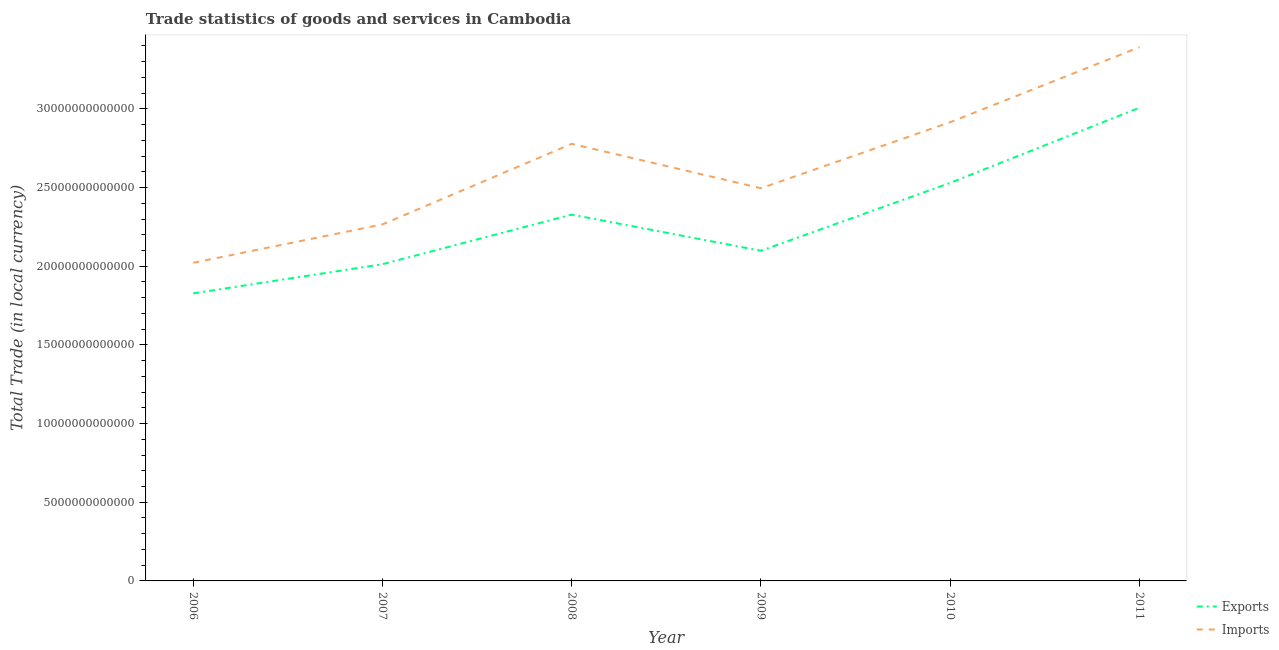Is the number of lines equal to the number of legend labels?
Your answer should be compact. Yes. What is the imports of goods and services in 2011?
Provide a short and direct response. 3.39e+13. Across all years, what is the maximum export of goods and services?
Make the answer very short. 3.01e+13. Across all years, what is the minimum export of goods and services?
Provide a short and direct response. 1.83e+13. In which year was the imports of goods and services maximum?
Offer a very short reply. 2011. What is the total imports of goods and services in the graph?
Give a very brief answer. 1.59e+14. What is the difference between the imports of goods and services in 2007 and that in 2009?
Offer a very short reply. -2.30e+12. What is the difference between the imports of goods and services in 2008 and the export of goods and services in 2010?
Your response must be concise. 2.48e+12. What is the average imports of goods and services per year?
Your response must be concise. 2.64e+13. In the year 2010, what is the difference between the imports of goods and services and export of goods and services?
Provide a succinct answer. 3.86e+12. What is the ratio of the imports of goods and services in 2008 to that in 2010?
Offer a very short reply. 0.95. Is the difference between the imports of goods and services in 2006 and 2011 greater than the difference between the export of goods and services in 2006 and 2011?
Provide a succinct answer. No. What is the difference between the highest and the second highest export of goods and services?
Give a very brief answer. 4.78e+12. What is the difference between the highest and the lowest export of goods and services?
Offer a very short reply. 1.18e+13. Does the imports of goods and services monotonically increase over the years?
Your answer should be compact. No. Is the imports of goods and services strictly greater than the export of goods and services over the years?
Provide a short and direct response. Yes. Is the export of goods and services strictly less than the imports of goods and services over the years?
Give a very brief answer. Yes. What is the difference between two consecutive major ticks on the Y-axis?
Offer a very short reply. 5.00e+12. Does the graph contain any zero values?
Your response must be concise. No. Where does the legend appear in the graph?
Make the answer very short. Bottom right. How many legend labels are there?
Give a very brief answer. 2. What is the title of the graph?
Make the answer very short. Trade statistics of goods and services in Cambodia. What is the label or title of the X-axis?
Provide a succinct answer. Year. What is the label or title of the Y-axis?
Offer a very short reply. Total Trade (in local currency). What is the Total Trade (in local currency) of Exports in 2006?
Your response must be concise. 1.83e+13. What is the Total Trade (in local currency) of Imports in 2006?
Offer a very short reply. 2.02e+13. What is the Total Trade (in local currency) in Exports in 2007?
Provide a short and direct response. 2.01e+13. What is the Total Trade (in local currency) of Imports in 2007?
Your response must be concise. 2.27e+13. What is the Total Trade (in local currency) in Exports in 2008?
Give a very brief answer. 2.33e+13. What is the Total Trade (in local currency) in Imports in 2008?
Keep it short and to the point. 2.78e+13. What is the Total Trade (in local currency) of Exports in 2009?
Your answer should be compact. 2.10e+13. What is the Total Trade (in local currency) of Imports in 2009?
Your response must be concise. 2.50e+13. What is the Total Trade (in local currency) in Exports in 2010?
Give a very brief answer. 2.53e+13. What is the Total Trade (in local currency) in Imports in 2010?
Your answer should be very brief. 2.92e+13. What is the Total Trade (in local currency) in Exports in 2011?
Give a very brief answer. 3.01e+13. What is the Total Trade (in local currency) of Imports in 2011?
Provide a short and direct response. 3.39e+13. Across all years, what is the maximum Total Trade (in local currency) in Exports?
Offer a terse response. 3.01e+13. Across all years, what is the maximum Total Trade (in local currency) in Imports?
Your answer should be very brief. 3.39e+13. Across all years, what is the minimum Total Trade (in local currency) of Exports?
Offer a terse response. 1.83e+13. Across all years, what is the minimum Total Trade (in local currency) of Imports?
Your response must be concise. 2.02e+13. What is the total Total Trade (in local currency) of Exports in the graph?
Offer a very short reply. 1.38e+14. What is the total Total Trade (in local currency) of Imports in the graph?
Offer a terse response. 1.59e+14. What is the difference between the Total Trade (in local currency) of Exports in 2006 and that in 2007?
Provide a short and direct response. -1.85e+12. What is the difference between the Total Trade (in local currency) in Imports in 2006 and that in 2007?
Ensure brevity in your answer.  -2.44e+12. What is the difference between the Total Trade (in local currency) in Exports in 2006 and that in 2008?
Your answer should be compact. -5.01e+12. What is the difference between the Total Trade (in local currency) of Imports in 2006 and that in 2008?
Offer a terse response. -7.56e+12. What is the difference between the Total Trade (in local currency) of Exports in 2006 and that in 2009?
Provide a succinct answer. -2.71e+12. What is the difference between the Total Trade (in local currency) of Imports in 2006 and that in 2009?
Your response must be concise. -4.74e+12. What is the difference between the Total Trade (in local currency) of Exports in 2006 and that in 2010?
Your response must be concise. -7.02e+12. What is the difference between the Total Trade (in local currency) of Imports in 2006 and that in 2010?
Your response must be concise. -8.94e+12. What is the difference between the Total Trade (in local currency) of Exports in 2006 and that in 2011?
Provide a succinct answer. -1.18e+13. What is the difference between the Total Trade (in local currency) in Imports in 2006 and that in 2011?
Offer a very short reply. -1.37e+13. What is the difference between the Total Trade (in local currency) of Exports in 2007 and that in 2008?
Give a very brief answer. -3.15e+12. What is the difference between the Total Trade (in local currency) in Imports in 2007 and that in 2008?
Your answer should be compact. -5.12e+12. What is the difference between the Total Trade (in local currency) of Exports in 2007 and that in 2009?
Offer a very short reply. -8.55e+11. What is the difference between the Total Trade (in local currency) in Imports in 2007 and that in 2009?
Ensure brevity in your answer.  -2.30e+12. What is the difference between the Total Trade (in local currency) of Exports in 2007 and that in 2010?
Provide a succinct answer. -5.17e+12. What is the difference between the Total Trade (in local currency) in Imports in 2007 and that in 2010?
Your answer should be very brief. -6.50e+12. What is the difference between the Total Trade (in local currency) of Exports in 2007 and that in 2011?
Your answer should be compact. -9.95e+12. What is the difference between the Total Trade (in local currency) of Imports in 2007 and that in 2011?
Your answer should be compact. -1.13e+13. What is the difference between the Total Trade (in local currency) of Exports in 2008 and that in 2009?
Your response must be concise. 2.30e+12. What is the difference between the Total Trade (in local currency) in Imports in 2008 and that in 2009?
Make the answer very short. 2.82e+12. What is the difference between the Total Trade (in local currency) in Exports in 2008 and that in 2010?
Make the answer very short. -2.02e+12. What is the difference between the Total Trade (in local currency) of Imports in 2008 and that in 2010?
Ensure brevity in your answer.  -1.38e+12. What is the difference between the Total Trade (in local currency) in Exports in 2008 and that in 2011?
Provide a succinct answer. -6.80e+12. What is the difference between the Total Trade (in local currency) of Imports in 2008 and that in 2011?
Your response must be concise. -6.14e+12. What is the difference between the Total Trade (in local currency) in Exports in 2009 and that in 2010?
Ensure brevity in your answer.  -4.31e+12. What is the difference between the Total Trade (in local currency) of Imports in 2009 and that in 2010?
Keep it short and to the point. -4.20e+12. What is the difference between the Total Trade (in local currency) in Exports in 2009 and that in 2011?
Your answer should be very brief. -9.09e+12. What is the difference between the Total Trade (in local currency) in Imports in 2009 and that in 2011?
Your answer should be compact. -8.97e+12. What is the difference between the Total Trade (in local currency) of Exports in 2010 and that in 2011?
Provide a succinct answer. -4.78e+12. What is the difference between the Total Trade (in local currency) of Imports in 2010 and that in 2011?
Your answer should be compact. -4.77e+12. What is the difference between the Total Trade (in local currency) of Exports in 2006 and the Total Trade (in local currency) of Imports in 2007?
Keep it short and to the point. -4.38e+12. What is the difference between the Total Trade (in local currency) of Exports in 2006 and the Total Trade (in local currency) of Imports in 2008?
Offer a terse response. -9.51e+12. What is the difference between the Total Trade (in local currency) in Exports in 2006 and the Total Trade (in local currency) in Imports in 2009?
Make the answer very short. -6.68e+12. What is the difference between the Total Trade (in local currency) in Exports in 2006 and the Total Trade (in local currency) in Imports in 2010?
Keep it short and to the point. -1.09e+13. What is the difference between the Total Trade (in local currency) of Exports in 2006 and the Total Trade (in local currency) of Imports in 2011?
Provide a short and direct response. -1.56e+13. What is the difference between the Total Trade (in local currency) of Exports in 2007 and the Total Trade (in local currency) of Imports in 2008?
Make the answer very short. -7.65e+12. What is the difference between the Total Trade (in local currency) of Exports in 2007 and the Total Trade (in local currency) of Imports in 2009?
Your answer should be very brief. -4.83e+12. What is the difference between the Total Trade (in local currency) in Exports in 2007 and the Total Trade (in local currency) in Imports in 2010?
Your answer should be very brief. -9.03e+12. What is the difference between the Total Trade (in local currency) of Exports in 2007 and the Total Trade (in local currency) of Imports in 2011?
Ensure brevity in your answer.  -1.38e+13. What is the difference between the Total Trade (in local currency) of Exports in 2008 and the Total Trade (in local currency) of Imports in 2009?
Keep it short and to the point. -1.68e+12. What is the difference between the Total Trade (in local currency) of Exports in 2008 and the Total Trade (in local currency) of Imports in 2010?
Your answer should be compact. -5.88e+12. What is the difference between the Total Trade (in local currency) in Exports in 2008 and the Total Trade (in local currency) in Imports in 2011?
Your answer should be very brief. -1.06e+13. What is the difference between the Total Trade (in local currency) in Exports in 2009 and the Total Trade (in local currency) in Imports in 2010?
Provide a short and direct response. -8.17e+12. What is the difference between the Total Trade (in local currency) of Exports in 2009 and the Total Trade (in local currency) of Imports in 2011?
Offer a terse response. -1.29e+13. What is the difference between the Total Trade (in local currency) in Exports in 2010 and the Total Trade (in local currency) in Imports in 2011?
Your answer should be very brief. -8.62e+12. What is the average Total Trade (in local currency) in Exports per year?
Your answer should be compact. 2.30e+13. What is the average Total Trade (in local currency) of Imports per year?
Your answer should be very brief. 2.64e+13. In the year 2006, what is the difference between the Total Trade (in local currency) of Exports and Total Trade (in local currency) of Imports?
Keep it short and to the point. -1.94e+12. In the year 2007, what is the difference between the Total Trade (in local currency) in Exports and Total Trade (in local currency) in Imports?
Your answer should be very brief. -2.53e+12. In the year 2008, what is the difference between the Total Trade (in local currency) in Exports and Total Trade (in local currency) in Imports?
Offer a very short reply. -4.50e+12. In the year 2009, what is the difference between the Total Trade (in local currency) of Exports and Total Trade (in local currency) of Imports?
Offer a terse response. -3.97e+12. In the year 2010, what is the difference between the Total Trade (in local currency) of Exports and Total Trade (in local currency) of Imports?
Provide a short and direct response. -3.86e+12. In the year 2011, what is the difference between the Total Trade (in local currency) in Exports and Total Trade (in local currency) in Imports?
Your response must be concise. -3.85e+12. What is the ratio of the Total Trade (in local currency) of Exports in 2006 to that in 2007?
Provide a short and direct response. 0.91. What is the ratio of the Total Trade (in local currency) in Imports in 2006 to that in 2007?
Ensure brevity in your answer.  0.89. What is the ratio of the Total Trade (in local currency) of Exports in 2006 to that in 2008?
Your answer should be compact. 0.79. What is the ratio of the Total Trade (in local currency) in Imports in 2006 to that in 2008?
Give a very brief answer. 0.73. What is the ratio of the Total Trade (in local currency) of Exports in 2006 to that in 2009?
Offer a terse response. 0.87. What is the ratio of the Total Trade (in local currency) of Imports in 2006 to that in 2009?
Provide a short and direct response. 0.81. What is the ratio of the Total Trade (in local currency) of Exports in 2006 to that in 2010?
Your answer should be compact. 0.72. What is the ratio of the Total Trade (in local currency) in Imports in 2006 to that in 2010?
Ensure brevity in your answer.  0.69. What is the ratio of the Total Trade (in local currency) in Exports in 2006 to that in 2011?
Your response must be concise. 0.61. What is the ratio of the Total Trade (in local currency) of Imports in 2006 to that in 2011?
Give a very brief answer. 0.6. What is the ratio of the Total Trade (in local currency) in Exports in 2007 to that in 2008?
Give a very brief answer. 0.86. What is the ratio of the Total Trade (in local currency) in Imports in 2007 to that in 2008?
Make the answer very short. 0.82. What is the ratio of the Total Trade (in local currency) in Exports in 2007 to that in 2009?
Give a very brief answer. 0.96. What is the ratio of the Total Trade (in local currency) of Imports in 2007 to that in 2009?
Provide a succinct answer. 0.91. What is the ratio of the Total Trade (in local currency) in Exports in 2007 to that in 2010?
Make the answer very short. 0.8. What is the ratio of the Total Trade (in local currency) of Imports in 2007 to that in 2010?
Keep it short and to the point. 0.78. What is the ratio of the Total Trade (in local currency) of Exports in 2007 to that in 2011?
Offer a very short reply. 0.67. What is the ratio of the Total Trade (in local currency) of Imports in 2007 to that in 2011?
Your response must be concise. 0.67. What is the ratio of the Total Trade (in local currency) of Exports in 2008 to that in 2009?
Keep it short and to the point. 1.11. What is the ratio of the Total Trade (in local currency) of Imports in 2008 to that in 2009?
Offer a very short reply. 1.11. What is the ratio of the Total Trade (in local currency) in Exports in 2008 to that in 2010?
Your answer should be very brief. 0.92. What is the ratio of the Total Trade (in local currency) in Imports in 2008 to that in 2010?
Provide a succinct answer. 0.95. What is the ratio of the Total Trade (in local currency) of Exports in 2008 to that in 2011?
Your answer should be very brief. 0.77. What is the ratio of the Total Trade (in local currency) in Imports in 2008 to that in 2011?
Your answer should be compact. 0.82. What is the ratio of the Total Trade (in local currency) of Exports in 2009 to that in 2010?
Offer a very short reply. 0.83. What is the ratio of the Total Trade (in local currency) of Imports in 2009 to that in 2010?
Offer a very short reply. 0.86. What is the ratio of the Total Trade (in local currency) of Exports in 2009 to that in 2011?
Keep it short and to the point. 0.7. What is the ratio of the Total Trade (in local currency) in Imports in 2009 to that in 2011?
Keep it short and to the point. 0.74. What is the ratio of the Total Trade (in local currency) in Exports in 2010 to that in 2011?
Give a very brief answer. 0.84. What is the ratio of the Total Trade (in local currency) of Imports in 2010 to that in 2011?
Offer a very short reply. 0.86. What is the difference between the highest and the second highest Total Trade (in local currency) in Exports?
Ensure brevity in your answer.  4.78e+12. What is the difference between the highest and the second highest Total Trade (in local currency) of Imports?
Offer a terse response. 4.77e+12. What is the difference between the highest and the lowest Total Trade (in local currency) in Exports?
Provide a succinct answer. 1.18e+13. What is the difference between the highest and the lowest Total Trade (in local currency) in Imports?
Provide a succinct answer. 1.37e+13. 